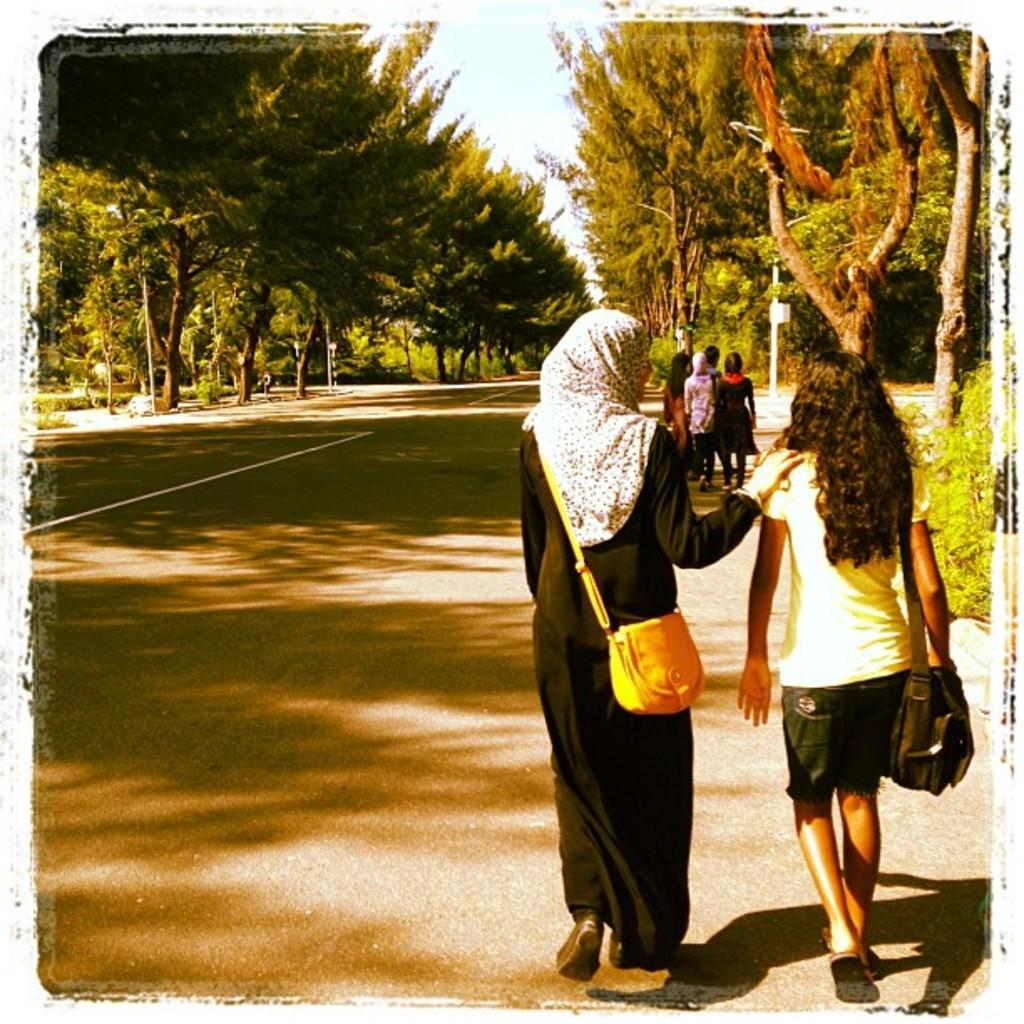How many women are in the image? There are two women in the image. What are the women doing in the image? The women are on a path and carrying bags. What can be seen in the background of the image? There are people and trees visible in the background of the image. What type of cheese is the father holding in the image? There is no father or cheese present in the image. What is the women rolling on the path in the image? There is no rolling object present in the image; the women are simply walking on the path while carrying bags. 